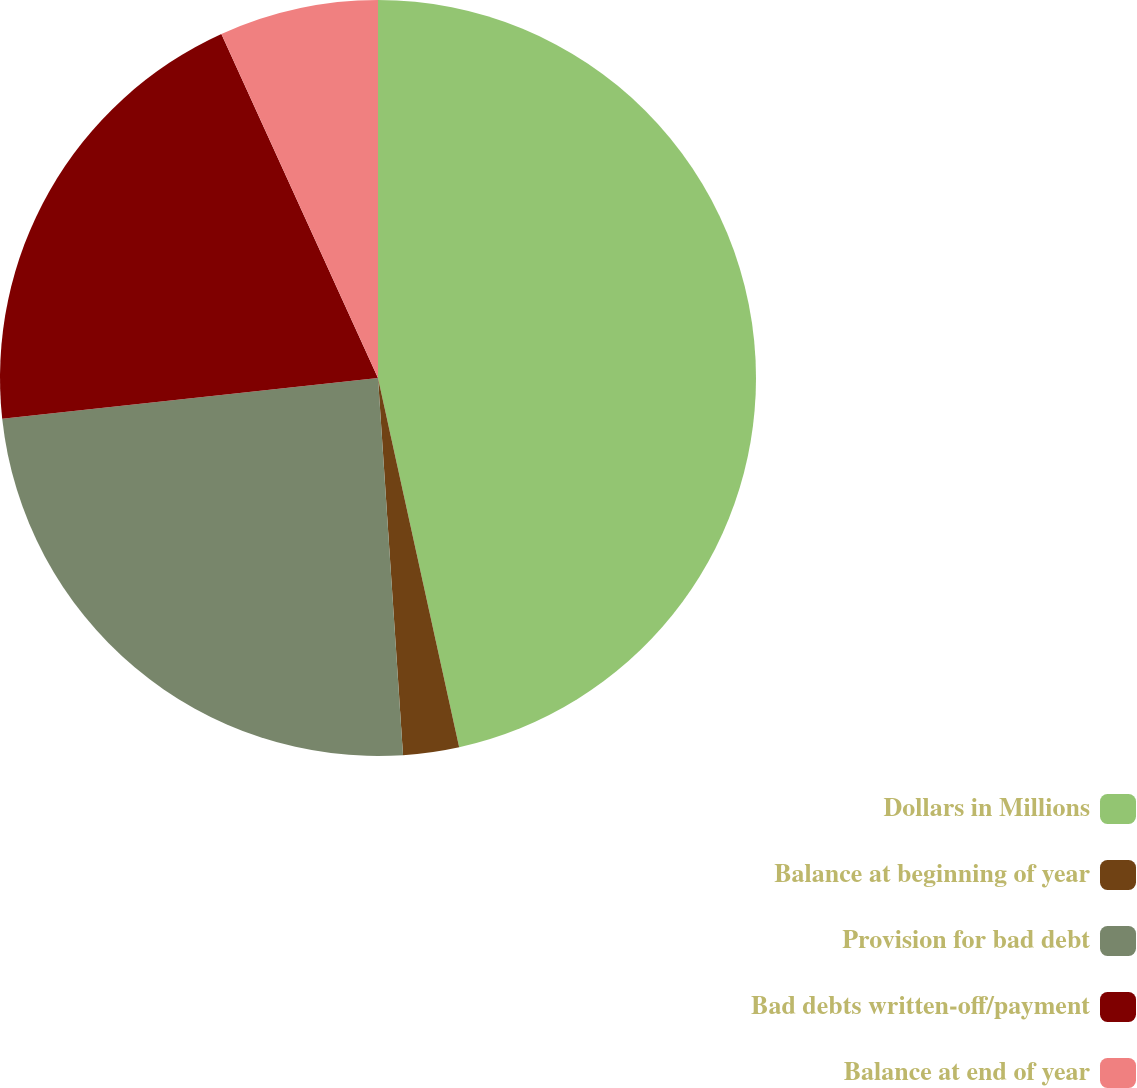Convert chart to OTSL. <chart><loc_0><loc_0><loc_500><loc_500><pie_chart><fcel>Dollars in Millions<fcel>Balance at beginning of year<fcel>Provision for bad debt<fcel>Bad debts written-off/payment<fcel>Balance at end of year<nl><fcel>46.56%<fcel>2.39%<fcel>24.34%<fcel>19.92%<fcel>6.8%<nl></chart> 